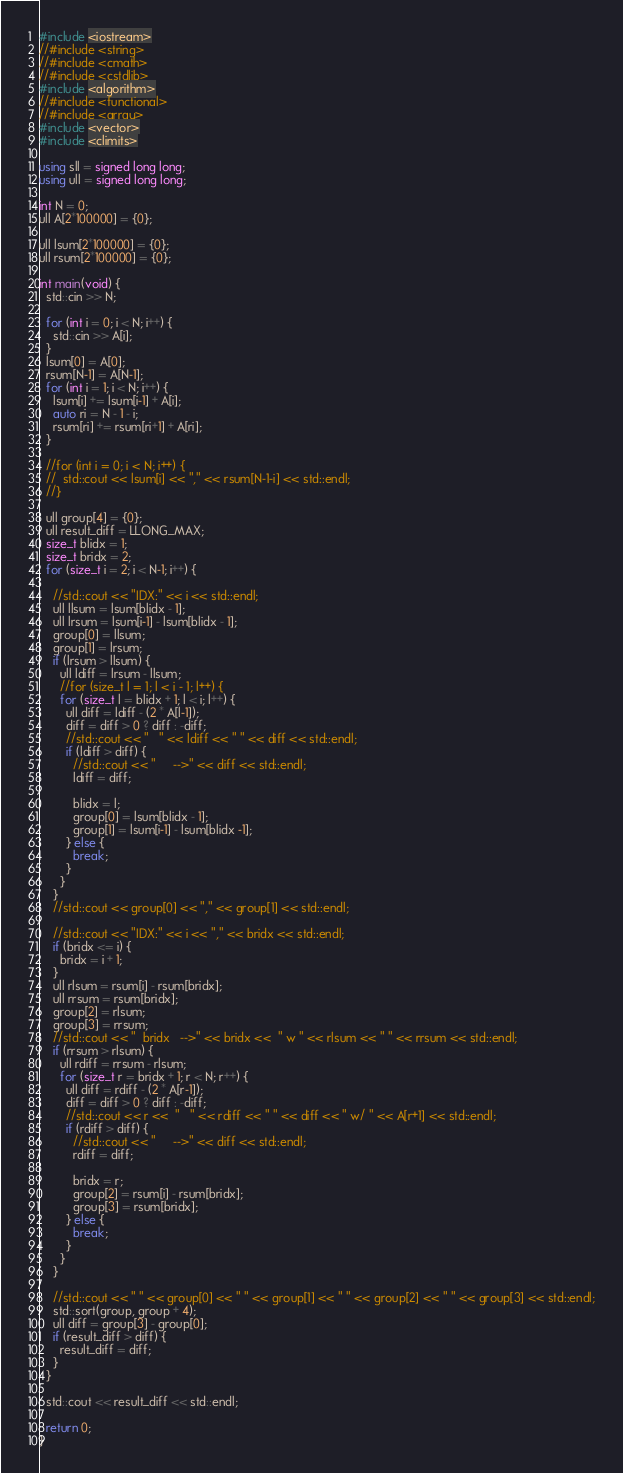Convert code to text. <code><loc_0><loc_0><loc_500><loc_500><_C++_>#include <iostream>
//#include <string>
//#include <cmath>
//#include <cstdlib>
#include <algorithm>
//#include <functional>
//#include <array>
#include <vector>
#include <climits>

using sll = signed long long;
using ull = signed long long;

int N = 0;
ull A[2*100000] = {0};

ull lsum[2*100000] = {0};
ull rsum[2*100000] = {0};

int main(void) {
  std::cin >> N;

  for (int i = 0; i < N; i++) {
    std::cin >> A[i];
  }
  lsum[0] = A[0];
  rsum[N-1] = A[N-1];
  for (int i = 1; i < N; i++) {
    lsum[i] += lsum[i-1] + A[i];
    auto ri = N - 1 - i;
    rsum[ri] += rsum[ri+1] + A[ri];
  }

  //for (int i = 0; i < N; i++) {
  //  std::cout << lsum[i] << "," << rsum[N-1-i] << std::endl;
  //}

  ull group[4] = {0};
  ull result_diff = LLONG_MAX;
  size_t blidx = 1;
  size_t bridx = 2;
  for (size_t i = 2; i < N-1; i++) {

    //std::cout << "IDX:" << i << std::endl;
    ull llsum = lsum[blidx - 1];
    ull lrsum = lsum[i-1] - lsum[blidx - 1];
    group[0] = llsum;
    group[1] = lrsum;
    if (lrsum > llsum) {
      ull ldiff = lrsum - llsum;
      //for (size_t l = 1; l < i - 1; l++) {
      for (size_t l = blidx + 1; l < i; l++) {
        ull diff = ldiff - (2 * A[l-1]);
        diff = diff > 0 ? diff : -diff;
        //std::cout << "   " << ldiff << " " << diff << std::endl;
        if (ldiff > diff) {
          //std::cout << "     -->" << diff << std::endl;
          ldiff = diff;

          blidx = l;
          group[0] = lsum[blidx - 1];
          group[1] = lsum[i-1] - lsum[blidx -1];
        } else {
          break;
        }
      }
    }
    //std::cout << group[0] << "," << group[1] << std::endl;

    //std::cout << "IDX:" << i << "," << bridx << std::endl;
    if (bridx <= i) {
      bridx = i + 1;
    }
    ull rlsum = rsum[i] - rsum[bridx];
    ull rrsum = rsum[bridx];
    group[2] = rlsum;
    group[3] = rrsum;
    //std::cout << "  bridx   -->" << bridx <<  " w " << rlsum << " " << rrsum << std::endl;
    if (rrsum > rlsum) {
      ull rdiff = rrsum - rlsum;
      for (size_t r = bridx + 1; r < N; r++) {
        ull diff = rdiff - (2 * A[r-1]);
        diff = diff > 0 ? diff : -diff;
        //std::cout << r <<  "   " << rdiff << " " << diff << " w/ " << A[r+1] << std::endl;
        if (rdiff > diff) {
          //std::cout << "     -->" << diff << std::endl;
          rdiff = diff;

          bridx = r;
          group[2] = rsum[i] - rsum[bridx];
          group[3] = rsum[bridx];
        } else {
          break;
        }
      }
    }

    //std::cout << " " << group[0] << " " << group[1] << " " << group[2] << " " << group[3] << std::endl;
    std::sort(group, group + 4);
    ull diff = group[3] - group[0];
    if (result_diff > diff) {
      result_diff = diff;
    }
  }

  std::cout << result_diff << std::endl;

  return 0;
}
</code> 